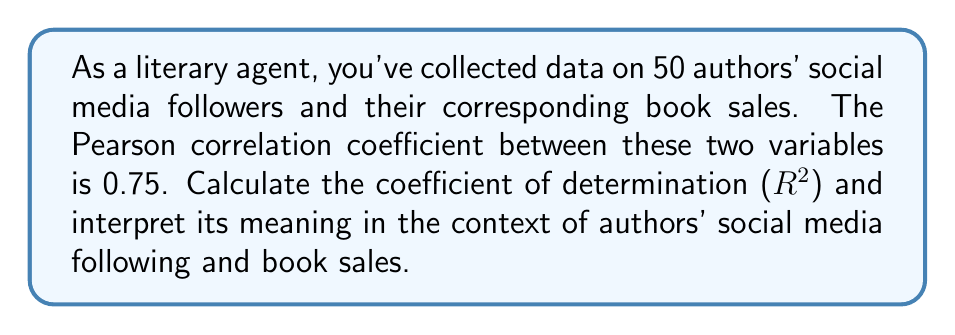Show me your answer to this math problem. To solve this problem, we'll follow these steps:

1. Recall the relationship between the Pearson correlation coefficient (r) and the coefficient of determination ($R^2$):

   $R^2 = r^2$

2. Given information:
   - Pearson correlation coefficient (r) = 0.75

3. Calculate $R^2$:
   $R^2 = (0.75)^2 = 0.5625$

4. Interpret the result:
   The coefficient of determination ($R^2$) of 0.5625 means that approximately 56.25% of the variance in book sales can be explained by the variance in an author's social media following.

   In the context of authors' social media following and book sales, this suggests a moderate to strong relationship between these two variables. While social media following appears to have a significant impact on book sales, there are other factors that also influence sales, accounting for the remaining 43.75% of the variance.

   As a literary agent, this information is valuable for assessing the potential marketability of new authors based on their social media presence, while also recognizing that it's not the sole determinant of success in book sales.
Answer: $R^2 = 0.5625$, indicating 56.25% of variance in book sales is explained by social media following. 